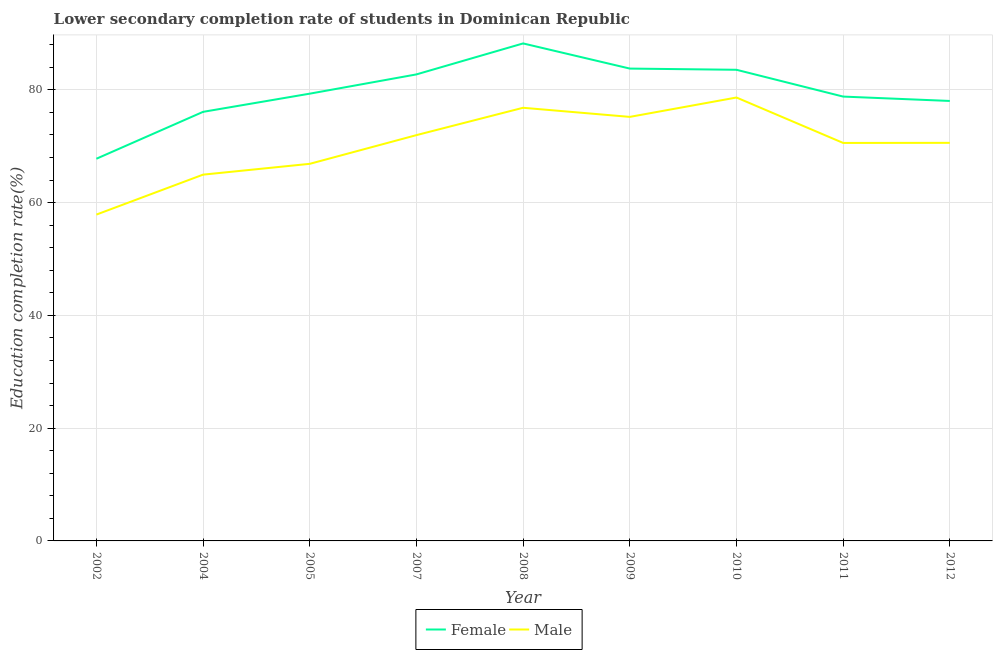How many different coloured lines are there?
Give a very brief answer. 2. Does the line corresponding to education completion rate of female students intersect with the line corresponding to education completion rate of male students?
Your answer should be compact. No. Is the number of lines equal to the number of legend labels?
Provide a short and direct response. Yes. What is the education completion rate of female students in 2005?
Offer a very short reply. 79.31. Across all years, what is the maximum education completion rate of male students?
Give a very brief answer. 78.63. Across all years, what is the minimum education completion rate of male students?
Offer a terse response. 57.87. In which year was the education completion rate of male students maximum?
Ensure brevity in your answer.  2010. What is the total education completion rate of female students in the graph?
Make the answer very short. 718.26. What is the difference between the education completion rate of male students in 2004 and that in 2010?
Offer a very short reply. -13.68. What is the difference between the education completion rate of male students in 2009 and the education completion rate of female students in 2008?
Provide a short and direct response. -13.03. What is the average education completion rate of female students per year?
Your answer should be compact. 79.81. In the year 2010, what is the difference between the education completion rate of female students and education completion rate of male students?
Your answer should be very brief. 4.92. In how many years, is the education completion rate of female students greater than 8 %?
Offer a terse response. 9. What is the ratio of the education completion rate of female students in 2002 to that in 2004?
Offer a terse response. 0.89. Is the education completion rate of male students in 2009 less than that in 2010?
Your answer should be very brief. Yes. What is the difference between the highest and the second highest education completion rate of male students?
Make the answer very short. 1.82. What is the difference between the highest and the lowest education completion rate of female students?
Offer a terse response. 20.45. In how many years, is the education completion rate of female students greater than the average education completion rate of female students taken over all years?
Give a very brief answer. 4. Is the education completion rate of female students strictly greater than the education completion rate of male students over the years?
Keep it short and to the point. Yes. Is the education completion rate of female students strictly less than the education completion rate of male students over the years?
Provide a short and direct response. No. Are the values on the major ticks of Y-axis written in scientific E-notation?
Provide a succinct answer. No. Does the graph contain grids?
Your response must be concise. Yes. Where does the legend appear in the graph?
Make the answer very short. Bottom center. How many legend labels are there?
Ensure brevity in your answer.  2. How are the legend labels stacked?
Make the answer very short. Horizontal. What is the title of the graph?
Your response must be concise. Lower secondary completion rate of students in Dominican Republic. What is the label or title of the X-axis?
Give a very brief answer. Year. What is the label or title of the Y-axis?
Ensure brevity in your answer.  Education completion rate(%). What is the Education completion rate(%) in Female in 2002?
Provide a short and direct response. 67.77. What is the Education completion rate(%) of Male in 2002?
Your answer should be very brief. 57.87. What is the Education completion rate(%) of Female in 2004?
Give a very brief answer. 76.09. What is the Education completion rate(%) in Male in 2004?
Make the answer very short. 64.95. What is the Education completion rate(%) in Female in 2005?
Make the answer very short. 79.31. What is the Education completion rate(%) of Male in 2005?
Offer a terse response. 66.87. What is the Education completion rate(%) of Female in 2007?
Your answer should be compact. 82.73. What is the Education completion rate(%) of Male in 2007?
Ensure brevity in your answer.  71.96. What is the Education completion rate(%) in Female in 2008?
Provide a succinct answer. 88.22. What is the Education completion rate(%) in Male in 2008?
Make the answer very short. 76.81. What is the Education completion rate(%) of Female in 2009?
Offer a terse response. 83.76. What is the Education completion rate(%) in Male in 2009?
Your response must be concise. 75.2. What is the Education completion rate(%) of Female in 2010?
Your answer should be very brief. 83.55. What is the Education completion rate(%) of Male in 2010?
Provide a short and direct response. 78.63. What is the Education completion rate(%) in Female in 2011?
Your response must be concise. 78.8. What is the Education completion rate(%) of Male in 2011?
Offer a very short reply. 70.58. What is the Education completion rate(%) in Female in 2012?
Give a very brief answer. 78.02. What is the Education completion rate(%) in Male in 2012?
Provide a succinct answer. 70.59. Across all years, what is the maximum Education completion rate(%) in Female?
Offer a terse response. 88.22. Across all years, what is the maximum Education completion rate(%) of Male?
Offer a terse response. 78.63. Across all years, what is the minimum Education completion rate(%) of Female?
Offer a terse response. 67.77. Across all years, what is the minimum Education completion rate(%) in Male?
Keep it short and to the point. 57.87. What is the total Education completion rate(%) in Female in the graph?
Offer a very short reply. 718.26. What is the total Education completion rate(%) of Male in the graph?
Your answer should be compact. 633.47. What is the difference between the Education completion rate(%) in Female in 2002 and that in 2004?
Provide a short and direct response. -8.32. What is the difference between the Education completion rate(%) in Male in 2002 and that in 2004?
Your response must be concise. -7.08. What is the difference between the Education completion rate(%) of Female in 2002 and that in 2005?
Provide a short and direct response. -11.54. What is the difference between the Education completion rate(%) of Male in 2002 and that in 2005?
Keep it short and to the point. -9. What is the difference between the Education completion rate(%) of Female in 2002 and that in 2007?
Provide a succinct answer. -14.96. What is the difference between the Education completion rate(%) in Male in 2002 and that in 2007?
Your answer should be very brief. -14.09. What is the difference between the Education completion rate(%) in Female in 2002 and that in 2008?
Give a very brief answer. -20.45. What is the difference between the Education completion rate(%) of Male in 2002 and that in 2008?
Offer a very short reply. -18.94. What is the difference between the Education completion rate(%) of Female in 2002 and that in 2009?
Offer a terse response. -15.99. What is the difference between the Education completion rate(%) of Male in 2002 and that in 2009?
Keep it short and to the point. -17.33. What is the difference between the Education completion rate(%) of Female in 2002 and that in 2010?
Your response must be concise. -15.78. What is the difference between the Education completion rate(%) in Male in 2002 and that in 2010?
Your answer should be compact. -20.76. What is the difference between the Education completion rate(%) in Female in 2002 and that in 2011?
Provide a succinct answer. -11.03. What is the difference between the Education completion rate(%) in Male in 2002 and that in 2011?
Keep it short and to the point. -12.71. What is the difference between the Education completion rate(%) in Female in 2002 and that in 2012?
Give a very brief answer. -10.25. What is the difference between the Education completion rate(%) in Male in 2002 and that in 2012?
Your answer should be very brief. -12.72. What is the difference between the Education completion rate(%) in Female in 2004 and that in 2005?
Your answer should be compact. -3.23. What is the difference between the Education completion rate(%) of Male in 2004 and that in 2005?
Your answer should be compact. -1.92. What is the difference between the Education completion rate(%) of Female in 2004 and that in 2007?
Offer a terse response. -6.64. What is the difference between the Education completion rate(%) of Male in 2004 and that in 2007?
Ensure brevity in your answer.  -7.01. What is the difference between the Education completion rate(%) in Female in 2004 and that in 2008?
Give a very brief answer. -12.13. What is the difference between the Education completion rate(%) in Male in 2004 and that in 2008?
Your answer should be compact. -11.86. What is the difference between the Education completion rate(%) of Female in 2004 and that in 2009?
Make the answer very short. -7.67. What is the difference between the Education completion rate(%) in Male in 2004 and that in 2009?
Your response must be concise. -10.24. What is the difference between the Education completion rate(%) of Female in 2004 and that in 2010?
Your response must be concise. -7.46. What is the difference between the Education completion rate(%) of Male in 2004 and that in 2010?
Keep it short and to the point. -13.68. What is the difference between the Education completion rate(%) of Female in 2004 and that in 2011?
Keep it short and to the point. -2.71. What is the difference between the Education completion rate(%) in Male in 2004 and that in 2011?
Give a very brief answer. -5.62. What is the difference between the Education completion rate(%) of Female in 2004 and that in 2012?
Ensure brevity in your answer.  -1.93. What is the difference between the Education completion rate(%) of Male in 2004 and that in 2012?
Offer a very short reply. -5.64. What is the difference between the Education completion rate(%) of Female in 2005 and that in 2007?
Your response must be concise. -3.42. What is the difference between the Education completion rate(%) of Male in 2005 and that in 2007?
Your answer should be compact. -5.09. What is the difference between the Education completion rate(%) in Female in 2005 and that in 2008?
Keep it short and to the point. -8.91. What is the difference between the Education completion rate(%) of Male in 2005 and that in 2008?
Provide a succinct answer. -9.94. What is the difference between the Education completion rate(%) in Female in 2005 and that in 2009?
Ensure brevity in your answer.  -4.45. What is the difference between the Education completion rate(%) of Male in 2005 and that in 2009?
Keep it short and to the point. -8.32. What is the difference between the Education completion rate(%) of Female in 2005 and that in 2010?
Make the answer very short. -4.23. What is the difference between the Education completion rate(%) of Male in 2005 and that in 2010?
Your answer should be compact. -11.76. What is the difference between the Education completion rate(%) in Female in 2005 and that in 2011?
Your response must be concise. 0.52. What is the difference between the Education completion rate(%) in Male in 2005 and that in 2011?
Your answer should be very brief. -3.71. What is the difference between the Education completion rate(%) of Female in 2005 and that in 2012?
Provide a short and direct response. 1.29. What is the difference between the Education completion rate(%) of Male in 2005 and that in 2012?
Offer a terse response. -3.72. What is the difference between the Education completion rate(%) of Female in 2007 and that in 2008?
Your response must be concise. -5.49. What is the difference between the Education completion rate(%) of Male in 2007 and that in 2008?
Your answer should be compact. -4.85. What is the difference between the Education completion rate(%) in Female in 2007 and that in 2009?
Ensure brevity in your answer.  -1.03. What is the difference between the Education completion rate(%) of Male in 2007 and that in 2009?
Give a very brief answer. -3.24. What is the difference between the Education completion rate(%) of Female in 2007 and that in 2010?
Offer a terse response. -0.82. What is the difference between the Education completion rate(%) of Male in 2007 and that in 2010?
Make the answer very short. -6.67. What is the difference between the Education completion rate(%) of Female in 2007 and that in 2011?
Provide a succinct answer. 3.93. What is the difference between the Education completion rate(%) in Male in 2007 and that in 2011?
Keep it short and to the point. 1.38. What is the difference between the Education completion rate(%) in Female in 2007 and that in 2012?
Ensure brevity in your answer.  4.71. What is the difference between the Education completion rate(%) in Male in 2007 and that in 2012?
Make the answer very short. 1.37. What is the difference between the Education completion rate(%) in Female in 2008 and that in 2009?
Offer a very short reply. 4.46. What is the difference between the Education completion rate(%) in Male in 2008 and that in 2009?
Your answer should be very brief. 1.62. What is the difference between the Education completion rate(%) in Female in 2008 and that in 2010?
Your response must be concise. 4.67. What is the difference between the Education completion rate(%) of Male in 2008 and that in 2010?
Give a very brief answer. -1.82. What is the difference between the Education completion rate(%) in Female in 2008 and that in 2011?
Your answer should be very brief. 9.42. What is the difference between the Education completion rate(%) in Male in 2008 and that in 2011?
Provide a short and direct response. 6.24. What is the difference between the Education completion rate(%) in Female in 2008 and that in 2012?
Your answer should be very brief. 10.2. What is the difference between the Education completion rate(%) of Male in 2008 and that in 2012?
Make the answer very short. 6.22. What is the difference between the Education completion rate(%) in Female in 2009 and that in 2010?
Offer a very short reply. 0.21. What is the difference between the Education completion rate(%) in Male in 2009 and that in 2010?
Provide a succinct answer. -3.43. What is the difference between the Education completion rate(%) of Female in 2009 and that in 2011?
Make the answer very short. 4.97. What is the difference between the Education completion rate(%) of Male in 2009 and that in 2011?
Make the answer very short. 4.62. What is the difference between the Education completion rate(%) of Female in 2009 and that in 2012?
Provide a succinct answer. 5.74. What is the difference between the Education completion rate(%) in Male in 2009 and that in 2012?
Offer a very short reply. 4.6. What is the difference between the Education completion rate(%) in Female in 2010 and that in 2011?
Your answer should be very brief. 4.75. What is the difference between the Education completion rate(%) of Male in 2010 and that in 2011?
Keep it short and to the point. 8.05. What is the difference between the Education completion rate(%) of Female in 2010 and that in 2012?
Your answer should be compact. 5.53. What is the difference between the Education completion rate(%) of Male in 2010 and that in 2012?
Offer a terse response. 8.04. What is the difference between the Education completion rate(%) in Female in 2011 and that in 2012?
Provide a short and direct response. 0.78. What is the difference between the Education completion rate(%) in Male in 2011 and that in 2012?
Ensure brevity in your answer.  -0.02. What is the difference between the Education completion rate(%) in Female in 2002 and the Education completion rate(%) in Male in 2004?
Your response must be concise. 2.82. What is the difference between the Education completion rate(%) in Female in 2002 and the Education completion rate(%) in Male in 2005?
Your response must be concise. 0.9. What is the difference between the Education completion rate(%) in Female in 2002 and the Education completion rate(%) in Male in 2007?
Give a very brief answer. -4.19. What is the difference between the Education completion rate(%) in Female in 2002 and the Education completion rate(%) in Male in 2008?
Your answer should be very brief. -9.04. What is the difference between the Education completion rate(%) of Female in 2002 and the Education completion rate(%) of Male in 2009?
Make the answer very short. -7.42. What is the difference between the Education completion rate(%) in Female in 2002 and the Education completion rate(%) in Male in 2010?
Provide a succinct answer. -10.86. What is the difference between the Education completion rate(%) in Female in 2002 and the Education completion rate(%) in Male in 2011?
Offer a very short reply. -2.81. What is the difference between the Education completion rate(%) of Female in 2002 and the Education completion rate(%) of Male in 2012?
Provide a short and direct response. -2.82. What is the difference between the Education completion rate(%) of Female in 2004 and the Education completion rate(%) of Male in 2005?
Keep it short and to the point. 9.22. What is the difference between the Education completion rate(%) of Female in 2004 and the Education completion rate(%) of Male in 2007?
Offer a terse response. 4.13. What is the difference between the Education completion rate(%) of Female in 2004 and the Education completion rate(%) of Male in 2008?
Make the answer very short. -0.72. What is the difference between the Education completion rate(%) of Female in 2004 and the Education completion rate(%) of Male in 2009?
Provide a short and direct response. 0.89. What is the difference between the Education completion rate(%) in Female in 2004 and the Education completion rate(%) in Male in 2010?
Your answer should be very brief. -2.54. What is the difference between the Education completion rate(%) in Female in 2004 and the Education completion rate(%) in Male in 2011?
Keep it short and to the point. 5.51. What is the difference between the Education completion rate(%) of Female in 2004 and the Education completion rate(%) of Male in 2012?
Provide a succinct answer. 5.5. What is the difference between the Education completion rate(%) of Female in 2005 and the Education completion rate(%) of Male in 2007?
Provide a short and direct response. 7.35. What is the difference between the Education completion rate(%) of Female in 2005 and the Education completion rate(%) of Male in 2008?
Ensure brevity in your answer.  2.5. What is the difference between the Education completion rate(%) in Female in 2005 and the Education completion rate(%) in Male in 2009?
Make the answer very short. 4.12. What is the difference between the Education completion rate(%) in Female in 2005 and the Education completion rate(%) in Male in 2010?
Your answer should be very brief. 0.68. What is the difference between the Education completion rate(%) of Female in 2005 and the Education completion rate(%) of Male in 2011?
Keep it short and to the point. 8.74. What is the difference between the Education completion rate(%) in Female in 2005 and the Education completion rate(%) in Male in 2012?
Make the answer very short. 8.72. What is the difference between the Education completion rate(%) of Female in 2007 and the Education completion rate(%) of Male in 2008?
Offer a very short reply. 5.92. What is the difference between the Education completion rate(%) in Female in 2007 and the Education completion rate(%) in Male in 2009?
Your response must be concise. 7.53. What is the difference between the Education completion rate(%) in Female in 2007 and the Education completion rate(%) in Male in 2010?
Offer a terse response. 4.1. What is the difference between the Education completion rate(%) of Female in 2007 and the Education completion rate(%) of Male in 2011?
Your answer should be very brief. 12.15. What is the difference between the Education completion rate(%) in Female in 2007 and the Education completion rate(%) in Male in 2012?
Give a very brief answer. 12.14. What is the difference between the Education completion rate(%) of Female in 2008 and the Education completion rate(%) of Male in 2009?
Provide a succinct answer. 13.03. What is the difference between the Education completion rate(%) in Female in 2008 and the Education completion rate(%) in Male in 2010?
Offer a very short reply. 9.59. What is the difference between the Education completion rate(%) in Female in 2008 and the Education completion rate(%) in Male in 2011?
Your answer should be compact. 17.64. What is the difference between the Education completion rate(%) of Female in 2008 and the Education completion rate(%) of Male in 2012?
Offer a terse response. 17.63. What is the difference between the Education completion rate(%) of Female in 2009 and the Education completion rate(%) of Male in 2010?
Provide a succinct answer. 5.13. What is the difference between the Education completion rate(%) in Female in 2009 and the Education completion rate(%) in Male in 2011?
Make the answer very short. 13.19. What is the difference between the Education completion rate(%) in Female in 2009 and the Education completion rate(%) in Male in 2012?
Provide a short and direct response. 13.17. What is the difference between the Education completion rate(%) in Female in 2010 and the Education completion rate(%) in Male in 2011?
Your response must be concise. 12.97. What is the difference between the Education completion rate(%) in Female in 2010 and the Education completion rate(%) in Male in 2012?
Offer a terse response. 12.96. What is the difference between the Education completion rate(%) of Female in 2011 and the Education completion rate(%) of Male in 2012?
Your answer should be compact. 8.2. What is the average Education completion rate(%) of Female per year?
Keep it short and to the point. 79.81. What is the average Education completion rate(%) in Male per year?
Keep it short and to the point. 70.39. In the year 2002, what is the difference between the Education completion rate(%) of Female and Education completion rate(%) of Male?
Provide a short and direct response. 9.9. In the year 2004, what is the difference between the Education completion rate(%) in Female and Education completion rate(%) in Male?
Provide a short and direct response. 11.14. In the year 2005, what is the difference between the Education completion rate(%) of Female and Education completion rate(%) of Male?
Ensure brevity in your answer.  12.44. In the year 2007, what is the difference between the Education completion rate(%) of Female and Education completion rate(%) of Male?
Your answer should be very brief. 10.77. In the year 2008, what is the difference between the Education completion rate(%) of Female and Education completion rate(%) of Male?
Keep it short and to the point. 11.41. In the year 2009, what is the difference between the Education completion rate(%) of Female and Education completion rate(%) of Male?
Offer a very short reply. 8.57. In the year 2010, what is the difference between the Education completion rate(%) in Female and Education completion rate(%) in Male?
Provide a short and direct response. 4.92. In the year 2011, what is the difference between the Education completion rate(%) of Female and Education completion rate(%) of Male?
Your answer should be compact. 8.22. In the year 2012, what is the difference between the Education completion rate(%) of Female and Education completion rate(%) of Male?
Offer a terse response. 7.43. What is the ratio of the Education completion rate(%) in Female in 2002 to that in 2004?
Give a very brief answer. 0.89. What is the ratio of the Education completion rate(%) in Male in 2002 to that in 2004?
Your answer should be very brief. 0.89. What is the ratio of the Education completion rate(%) in Female in 2002 to that in 2005?
Your response must be concise. 0.85. What is the ratio of the Education completion rate(%) of Male in 2002 to that in 2005?
Your answer should be compact. 0.87. What is the ratio of the Education completion rate(%) of Female in 2002 to that in 2007?
Keep it short and to the point. 0.82. What is the ratio of the Education completion rate(%) of Male in 2002 to that in 2007?
Your answer should be very brief. 0.8. What is the ratio of the Education completion rate(%) of Female in 2002 to that in 2008?
Keep it short and to the point. 0.77. What is the ratio of the Education completion rate(%) of Male in 2002 to that in 2008?
Provide a short and direct response. 0.75. What is the ratio of the Education completion rate(%) of Female in 2002 to that in 2009?
Offer a terse response. 0.81. What is the ratio of the Education completion rate(%) of Male in 2002 to that in 2009?
Keep it short and to the point. 0.77. What is the ratio of the Education completion rate(%) in Female in 2002 to that in 2010?
Your response must be concise. 0.81. What is the ratio of the Education completion rate(%) in Male in 2002 to that in 2010?
Give a very brief answer. 0.74. What is the ratio of the Education completion rate(%) of Female in 2002 to that in 2011?
Offer a very short reply. 0.86. What is the ratio of the Education completion rate(%) in Male in 2002 to that in 2011?
Ensure brevity in your answer.  0.82. What is the ratio of the Education completion rate(%) in Female in 2002 to that in 2012?
Give a very brief answer. 0.87. What is the ratio of the Education completion rate(%) in Male in 2002 to that in 2012?
Keep it short and to the point. 0.82. What is the ratio of the Education completion rate(%) of Female in 2004 to that in 2005?
Provide a succinct answer. 0.96. What is the ratio of the Education completion rate(%) in Male in 2004 to that in 2005?
Your answer should be very brief. 0.97. What is the ratio of the Education completion rate(%) of Female in 2004 to that in 2007?
Offer a very short reply. 0.92. What is the ratio of the Education completion rate(%) in Male in 2004 to that in 2007?
Provide a short and direct response. 0.9. What is the ratio of the Education completion rate(%) in Female in 2004 to that in 2008?
Ensure brevity in your answer.  0.86. What is the ratio of the Education completion rate(%) in Male in 2004 to that in 2008?
Make the answer very short. 0.85. What is the ratio of the Education completion rate(%) of Female in 2004 to that in 2009?
Your answer should be compact. 0.91. What is the ratio of the Education completion rate(%) in Male in 2004 to that in 2009?
Your response must be concise. 0.86. What is the ratio of the Education completion rate(%) in Female in 2004 to that in 2010?
Make the answer very short. 0.91. What is the ratio of the Education completion rate(%) in Male in 2004 to that in 2010?
Make the answer very short. 0.83. What is the ratio of the Education completion rate(%) of Female in 2004 to that in 2011?
Your answer should be very brief. 0.97. What is the ratio of the Education completion rate(%) in Male in 2004 to that in 2011?
Your answer should be compact. 0.92. What is the ratio of the Education completion rate(%) of Female in 2004 to that in 2012?
Your answer should be very brief. 0.98. What is the ratio of the Education completion rate(%) of Male in 2004 to that in 2012?
Your answer should be very brief. 0.92. What is the ratio of the Education completion rate(%) in Female in 2005 to that in 2007?
Give a very brief answer. 0.96. What is the ratio of the Education completion rate(%) of Male in 2005 to that in 2007?
Keep it short and to the point. 0.93. What is the ratio of the Education completion rate(%) in Female in 2005 to that in 2008?
Ensure brevity in your answer.  0.9. What is the ratio of the Education completion rate(%) of Male in 2005 to that in 2008?
Your answer should be compact. 0.87. What is the ratio of the Education completion rate(%) of Female in 2005 to that in 2009?
Offer a terse response. 0.95. What is the ratio of the Education completion rate(%) in Male in 2005 to that in 2009?
Give a very brief answer. 0.89. What is the ratio of the Education completion rate(%) of Female in 2005 to that in 2010?
Ensure brevity in your answer.  0.95. What is the ratio of the Education completion rate(%) in Male in 2005 to that in 2010?
Offer a terse response. 0.85. What is the ratio of the Education completion rate(%) of Female in 2005 to that in 2011?
Make the answer very short. 1.01. What is the ratio of the Education completion rate(%) of Male in 2005 to that in 2011?
Offer a very short reply. 0.95. What is the ratio of the Education completion rate(%) in Female in 2005 to that in 2012?
Your answer should be very brief. 1.02. What is the ratio of the Education completion rate(%) in Male in 2005 to that in 2012?
Provide a short and direct response. 0.95. What is the ratio of the Education completion rate(%) of Female in 2007 to that in 2008?
Your answer should be very brief. 0.94. What is the ratio of the Education completion rate(%) in Male in 2007 to that in 2008?
Your response must be concise. 0.94. What is the ratio of the Education completion rate(%) in Male in 2007 to that in 2009?
Provide a succinct answer. 0.96. What is the ratio of the Education completion rate(%) in Female in 2007 to that in 2010?
Offer a terse response. 0.99. What is the ratio of the Education completion rate(%) in Male in 2007 to that in 2010?
Your response must be concise. 0.92. What is the ratio of the Education completion rate(%) of Female in 2007 to that in 2011?
Your response must be concise. 1.05. What is the ratio of the Education completion rate(%) of Male in 2007 to that in 2011?
Keep it short and to the point. 1.02. What is the ratio of the Education completion rate(%) in Female in 2007 to that in 2012?
Provide a short and direct response. 1.06. What is the ratio of the Education completion rate(%) in Male in 2007 to that in 2012?
Provide a short and direct response. 1.02. What is the ratio of the Education completion rate(%) in Female in 2008 to that in 2009?
Provide a short and direct response. 1.05. What is the ratio of the Education completion rate(%) of Male in 2008 to that in 2009?
Your answer should be very brief. 1.02. What is the ratio of the Education completion rate(%) in Female in 2008 to that in 2010?
Provide a short and direct response. 1.06. What is the ratio of the Education completion rate(%) in Male in 2008 to that in 2010?
Provide a short and direct response. 0.98. What is the ratio of the Education completion rate(%) of Female in 2008 to that in 2011?
Give a very brief answer. 1.12. What is the ratio of the Education completion rate(%) of Male in 2008 to that in 2011?
Offer a very short reply. 1.09. What is the ratio of the Education completion rate(%) of Female in 2008 to that in 2012?
Provide a succinct answer. 1.13. What is the ratio of the Education completion rate(%) in Male in 2008 to that in 2012?
Make the answer very short. 1.09. What is the ratio of the Education completion rate(%) in Male in 2009 to that in 2010?
Your answer should be compact. 0.96. What is the ratio of the Education completion rate(%) of Female in 2009 to that in 2011?
Keep it short and to the point. 1.06. What is the ratio of the Education completion rate(%) in Male in 2009 to that in 2011?
Provide a short and direct response. 1.07. What is the ratio of the Education completion rate(%) in Female in 2009 to that in 2012?
Ensure brevity in your answer.  1.07. What is the ratio of the Education completion rate(%) in Male in 2009 to that in 2012?
Keep it short and to the point. 1.07. What is the ratio of the Education completion rate(%) in Female in 2010 to that in 2011?
Provide a succinct answer. 1.06. What is the ratio of the Education completion rate(%) of Male in 2010 to that in 2011?
Your answer should be very brief. 1.11. What is the ratio of the Education completion rate(%) in Female in 2010 to that in 2012?
Your answer should be compact. 1.07. What is the ratio of the Education completion rate(%) of Male in 2010 to that in 2012?
Your answer should be very brief. 1.11. What is the ratio of the Education completion rate(%) of Female in 2011 to that in 2012?
Offer a terse response. 1.01. What is the ratio of the Education completion rate(%) in Male in 2011 to that in 2012?
Your answer should be compact. 1. What is the difference between the highest and the second highest Education completion rate(%) of Female?
Give a very brief answer. 4.46. What is the difference between the highest and the second highest Education completion rate(%) in Male?
Offer a terse response. 1.82. What is the difference between the highest and the lowest Education completion rate(%) of Female?
Keep it short and to the point. 20.45. What is the difference between the highest and the lowest Education completion rate(%) of Male?
Give a very brief answer. 20.76. 